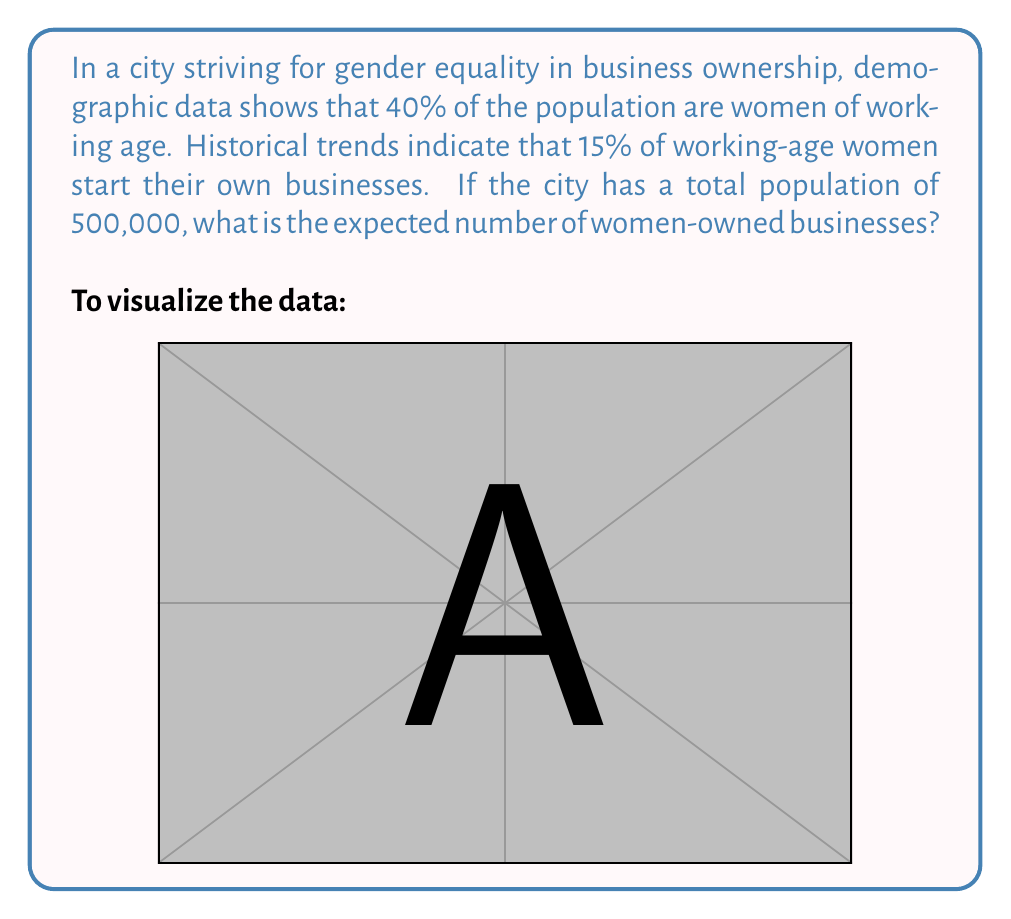Could you help me with this problem? Let's break this down step-by-step:

1) First, we need to calculate the number of women of working age in the city:
   $$ \text{Women of working age} = \text{Total population} \times \text{Percentage of women of working age} $$
   $$ \text{Women of working age} = 500,000 \times 0.40 = 200,000 $$

2) Next, we need to determine the probability of a woman of working age starting her own business:
   $$ P(\text{woman starts business}) = 0.15 $$

3) The expected number of women-owned businesses is the product of the number of women of working age and the probability of each starting a business:
   $$ E(\text{women-owned businesses}) = \text{Women of working age} \times P(\text{woman starts business}) $$
   $$ E(\text{women-owned businesses}) = 200,000 \times 0.15 = 30,000 $$

Therefore, the expected number of women-owned businesses in the city is 30,000.
Answer: 30,000 women-owned businesses 